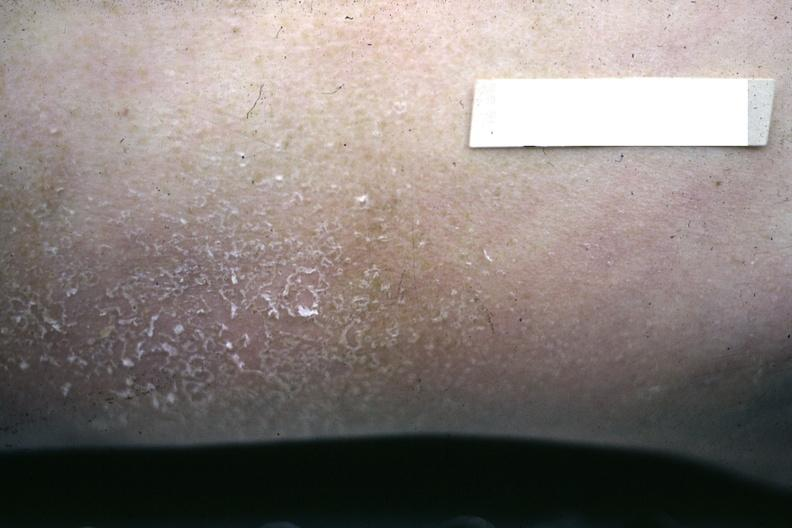what is present?
Answer the question using a single word or phrase. Uremic frost 